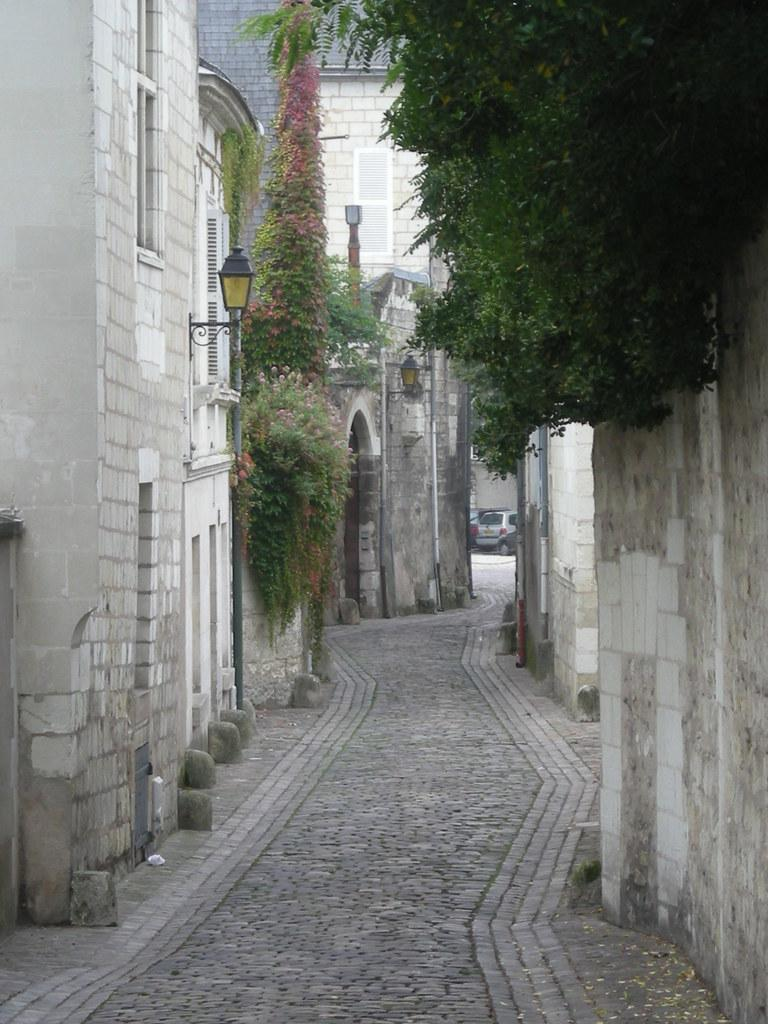What is the main feature in the center of the image? There is a walkway in the center of the image. What type of structures can be seen in the image? There are buildings in the image. What natural elements are present in the image? Trees are present in the image. What mode of transportation can be seen in the image? There is a car in the image. What can be used to illuminate the scene in the image? Lights are visible in the image. What type of crack can be seen on the side of the brick building in the image? There is no brick building present in the image, so it is not possible to answer that question. 